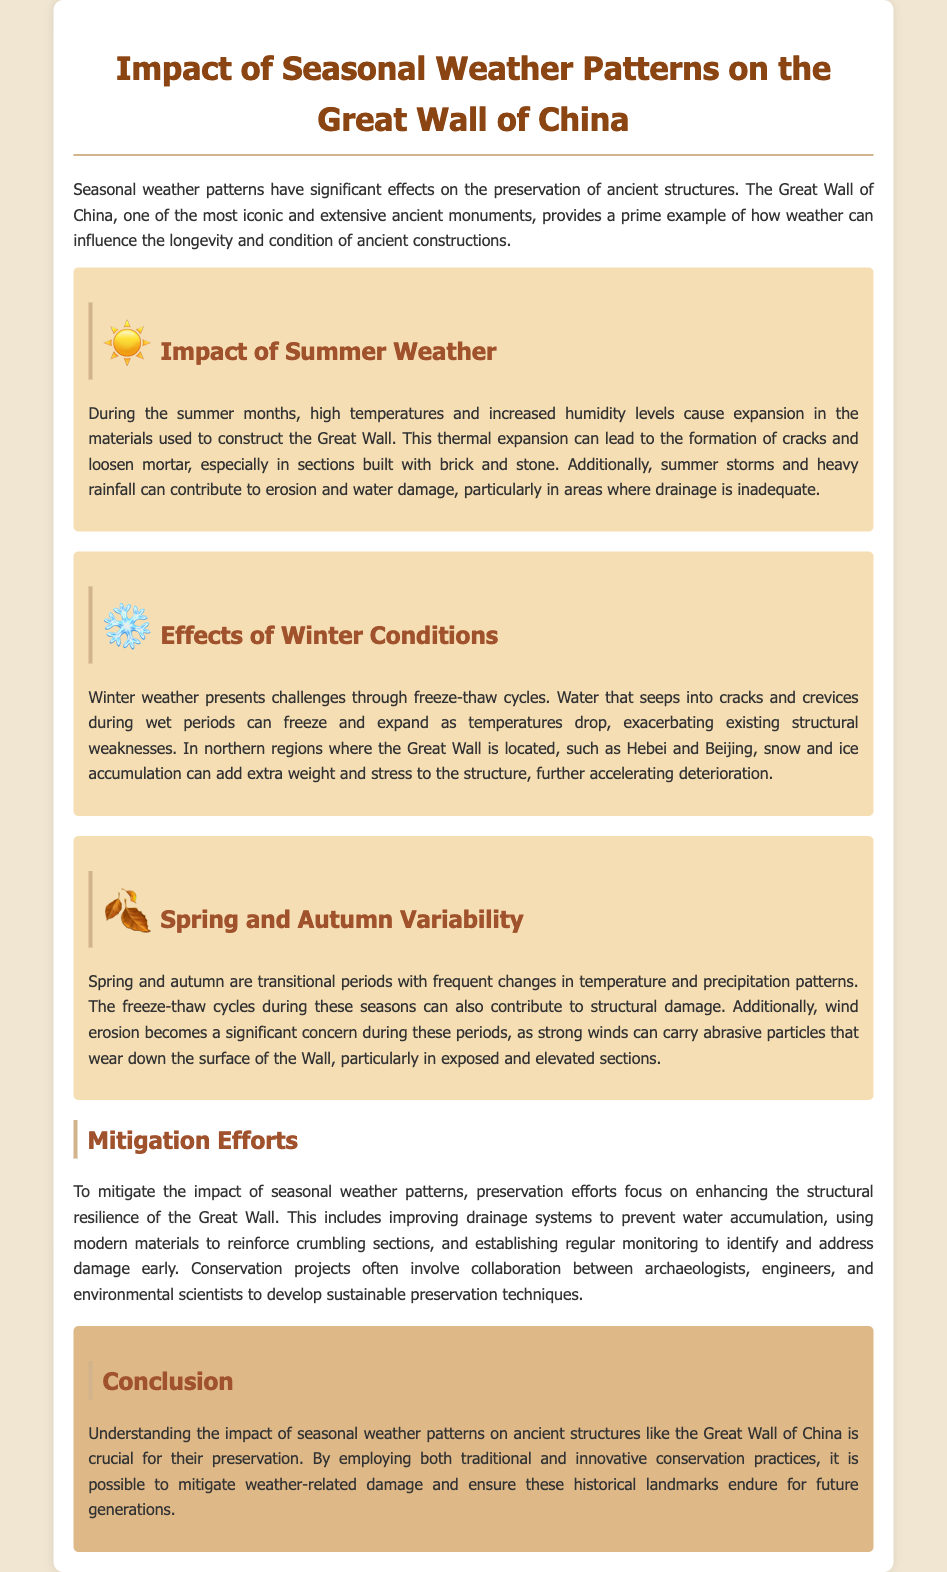What are the effects of summer weather on the Great Wall? The document states that high temperatures and increased humidity levels cause expansion in materials, leading to cracks and loosened mortar.
Answer: Expansion, cracks, and loosened mortar What challenges does winter weather pose to the Great Wall? The text describes freeze-thaw cycles where water freezes in cracks, expanding and exacerbating structural weaknesses.
Answer: Freeze-thaw cycles Which seasons have variability in temperature and precipitation patterns? The document mentions that spring and autumn are transitional periods with such variability.
Answer: Spring and autumn What mitigation efforts are mentioned in the report? The document lists improving drainage systems, using modern materials for reinforcement, and establishing regular monitoring.
Answer: Improving drainage, modern materials, regular monitoring What is the primary focus of the conclusion regarding preservation? The conclusion emphasizes the importance of employing traditional and innovative conservation practices to mitigate weather-related damage.
Answer: Traditional and innovative conservation practices In which regions of China is the Great Wall located? The document identifies northern regions like Hebei and Beijing as areas where the Great Wall is situated.
Answer: Hebei and Beijing What phenomenon adds extra weight to the structure during winter? The report states that snow and ice accumulation can add extra weight and stress during winter conditions.
Answer: Snow and ice accumulation What is a major concern during spring and autumn according to the document? The text highlights wind erosion as a significant concern due to strong winds carrying abrasive particles.
Answer: Wind erosion 